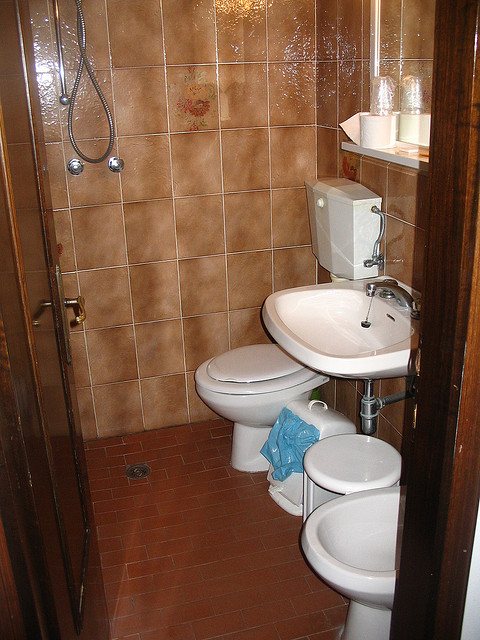This bathroom seems quite compact. Could you give some advice on how to make a small bathroom appear more spacious? To make a small bathroom feel more spacious, you can use light colors for walls and tiles, incorporate mirrors to reflect light and create an illusion of depth, and opt for space-saving fixtures. Organizing essentials and reducing clutter also helps in giving a more open, airy feel to the room. 